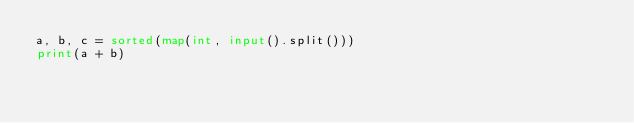<code> <loc_0><loc_0><loc_500><loc_500><_Python_>a, b, c = sorted(map(int, input().split()))
print(a + b)</code> 